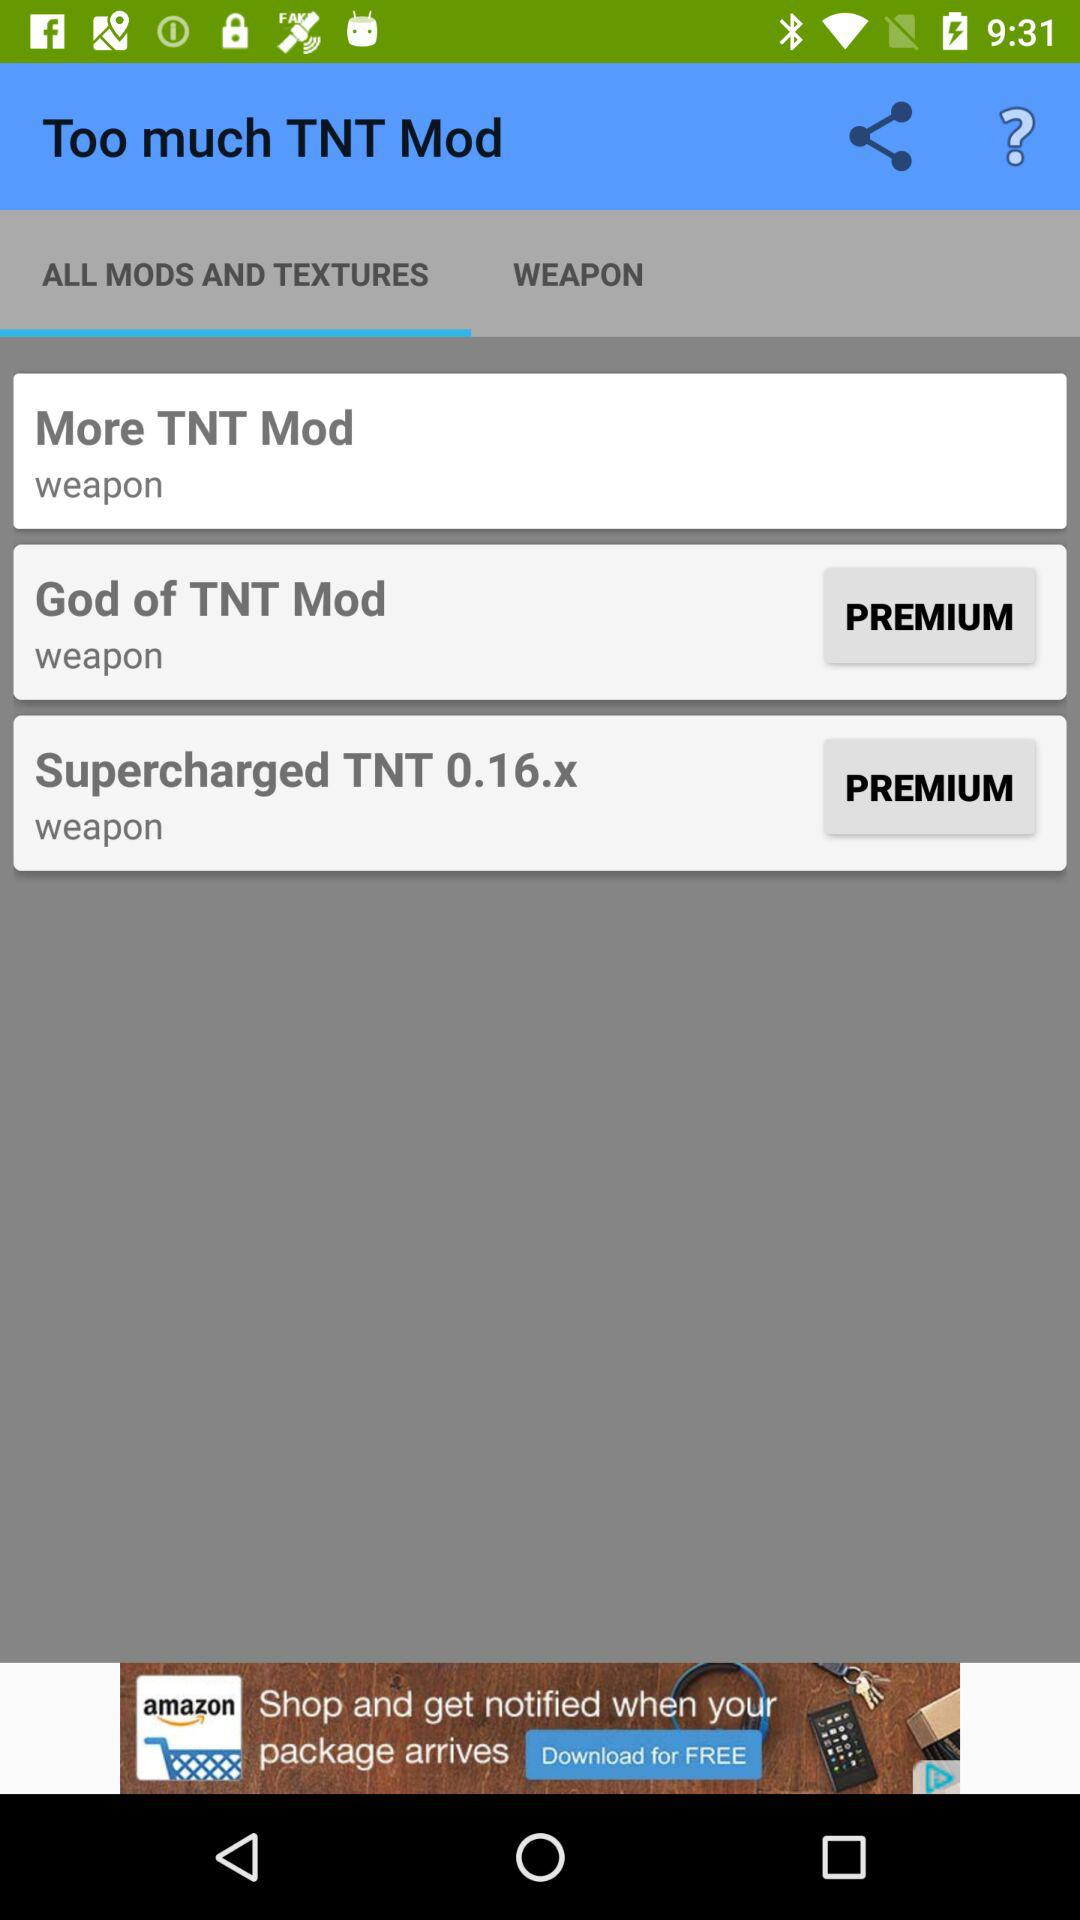Which tab is selected? The selected tab is "ALL MODS AND TEXTURES". 